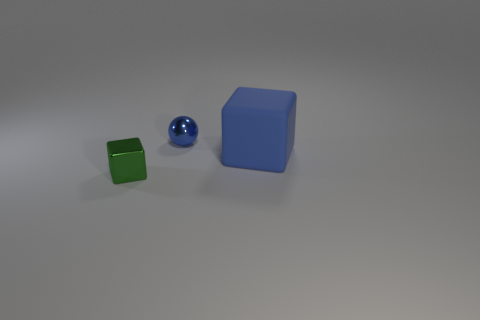Subtract all blue blocks. How many blocks are left? 1 Add 3 tiny metallic spheres. How many objects exist? 6 Subtract all spheres. How many objects are left? 2 Subtract all red cubes. Subtract all yellow cylinders. How many cubes are left? 2 Subtract all yellow spheres. How many green cubes are left? 1 Subtract all large purple balls. Subtract all small things. How many objects are left? 1 Add 3 big rubber blocks. How many big rubber blocks are left? 4 Add 2 balls. How many balls exist? 3 Subtract 1 blue cubes. How many objects are left? 2 Subtract 1 cubes. How many cubes are left? 1 